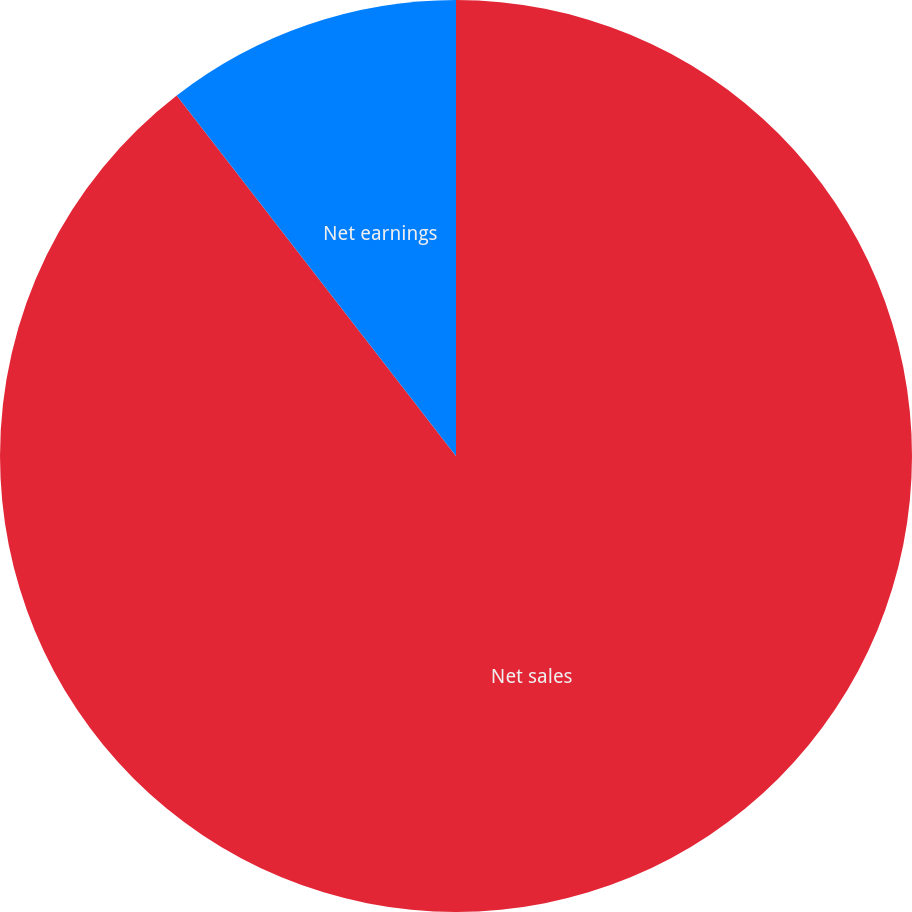Convert chart to OTSL. <chart><loc_0><loc_0><loc_500><loc_500><pie_chart><fcel>Net sales<fcel>Net earnings<nl><fcel>89.51%<fcel>10.49%<nl></chart> 